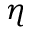Convert formula to latex. <formula><loc_0><loc_0><loc_500><loc_500>\eta</formula> 